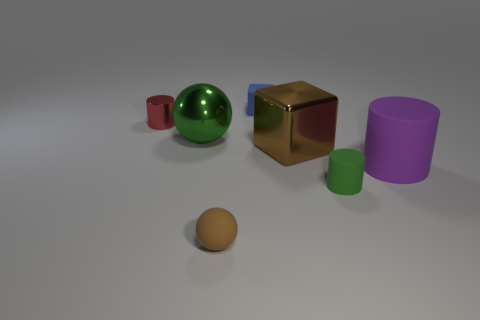What material is the object that is the same color as the metallic block?
Keep it short and to the point. Rubber. Do the tiny block and the tiny cylinder that is right of the red thing have the same material?
Make the answer very short. Yes. Is there any other thing that has the same size as the blue thing?
Your response must be concise. Yes. What number of things are either large things or objects behind the green matte cylinder?
Your answer should be compact. 5. There is a cylinder that is on the left side of the tiny matte cylinder; is its size the same as the green object that is behind the big matte thing?
Offer a terse response. No. How many other objects are the same color as the metal sphere?
Give a very brief answer. 1. There is a red metallic cylinder; is it the same size as the green thing on the left side of the metallic cube?
Provide a short and direct response. No. What is the size of the rubber cylinder on the left side of the cylinder that is to the right of the small green matte object?
Make the answer very short. Small. There is another tiny thing that is the same shape as the tiny green object; what is its color?
Offer a terse response. Red. Do the matte cube and the green ball have the same size?
Keep it short and to the point. No. 